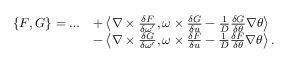<formula> <loc_0><loc_0><loc_500><loc_500>\begin{array} { r l } { \{ F , G \} = \dots } & { + \left \langle \nabla \times \frac { \delta F } { \delta \omega ^ { \prime } } , \omega \times \frac { \delta G } { \delta u } - \frac { 1 } { D } \frac { \delta G } { \delta \theta } \nabla \theta \right \rangle } \\ & { - \left \langle \nabla \times \frac { \delta G } { \delta \omega ^ { \prime } } , \omega \times \frac { \delta F } { \delta u } - \frac { 1 } { D } \frac { \delta F } { \delta \theta } \nabla \theta \right \rangle . } \end{array}</formula> 